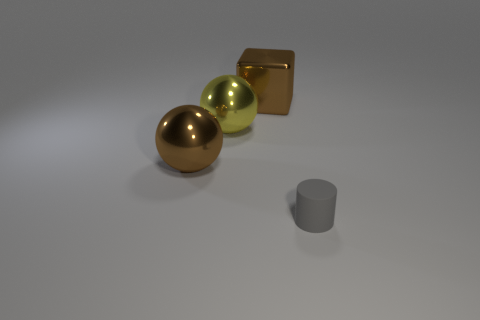How are the shadows of the objects interacting? The objects cast shadows that extend towards the right, indicating a light source to the left of the scene. The sphere and cube cast rounded shadows, while the cylinder projects an elongated shadow with straight edges. 